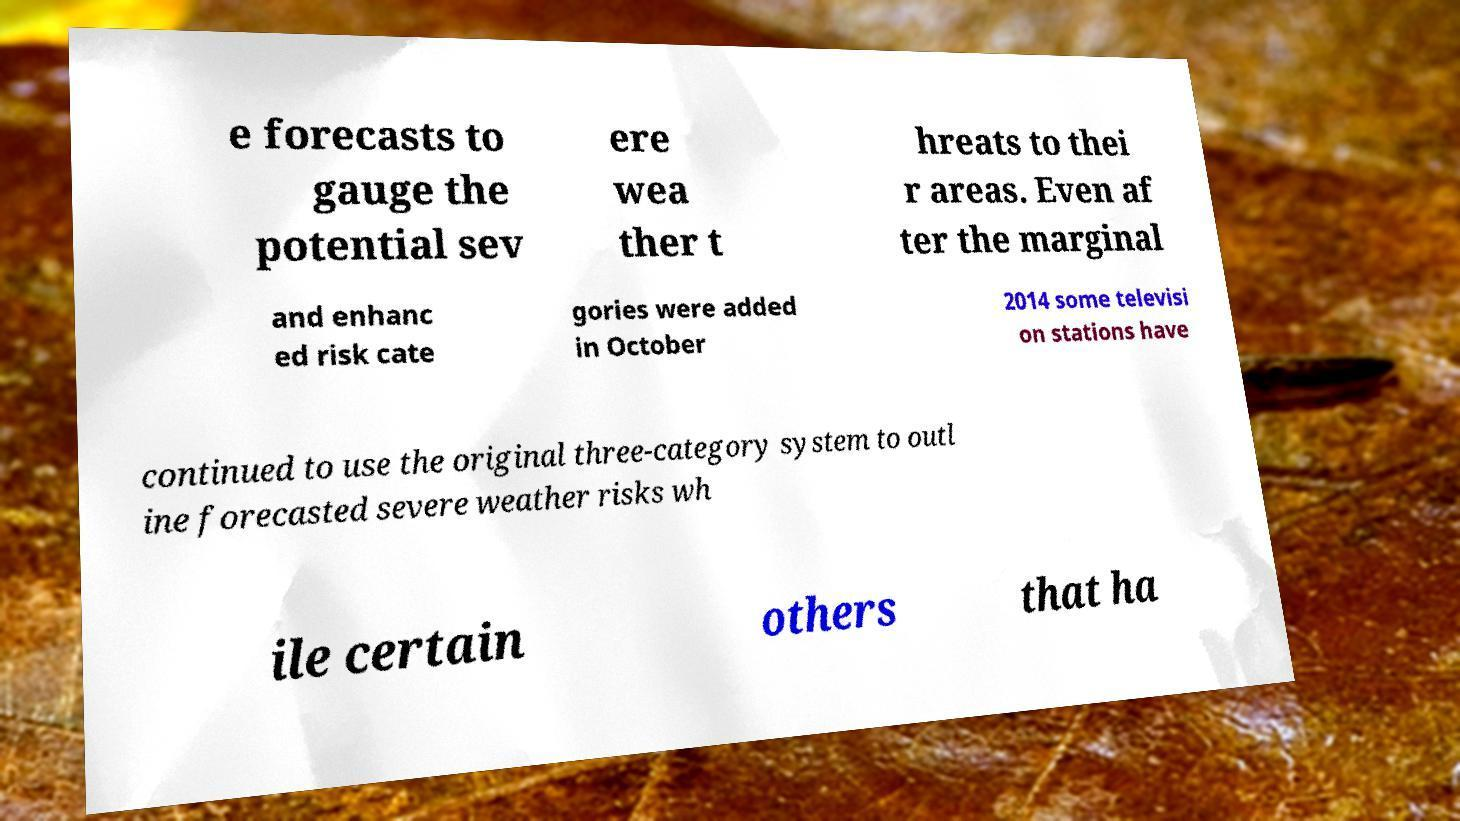For documentation purposes, I need the text within this image transcribed. Could you provide that? e forecasts to gauge the potential sev ere wea ther t hreats to thei r areas. Even af ter the marginal and enhanc ed risk cate gories were added in October 2014 some televisi on stations have continued to use the original three-category system to outl ine forecasted severe weather risks wh ile certain others that ha 